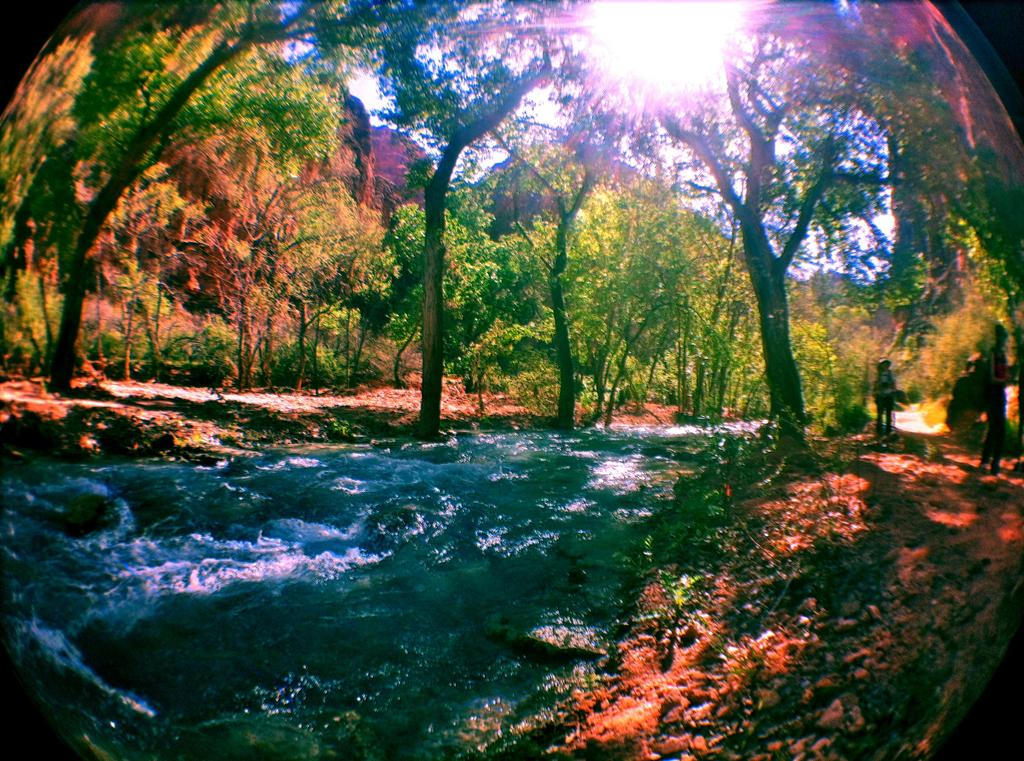What is happening in the middle of the image? Water is flowing in the middle of the image. Who or what can be seen on the right side of the image? There are two persons on the right side of the image. What type of vegetation is present in the image? There are big trees in the image. What type of bat is flying over the water in the image? There is no bat present in the image; it features water flowing and two persons on the right side. What type of war is depicted in the image? There is no war depicted in the image; it features water flowing, two persons, and big trees. 